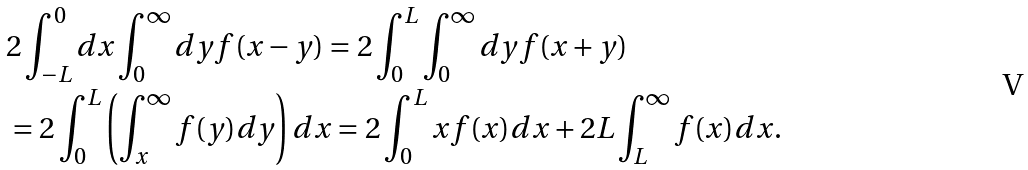Convert formula to latex. <formula><loc_0><loc_0><loc_500><loc_500>& 2 \int _ { - L } ^ { 0 } d x \int _ { 0 } ^ { \infty } d y f ( x - y ) = 2 \int _ { 0 } ^ { L } \int _ { 0 } ^ { \infty } d y f ( x + y ) \\ & = 2 \int _ { 0 } ^ { L } \left ( \int _ { x } ^ { \infty } f ( y ) d y \right ) d x = 2 \int _ { 0 } ^ { L } x f ( x ) d x + 2 L \int _ { L } ^ { \infty } f ( x ) d x .</formula> 